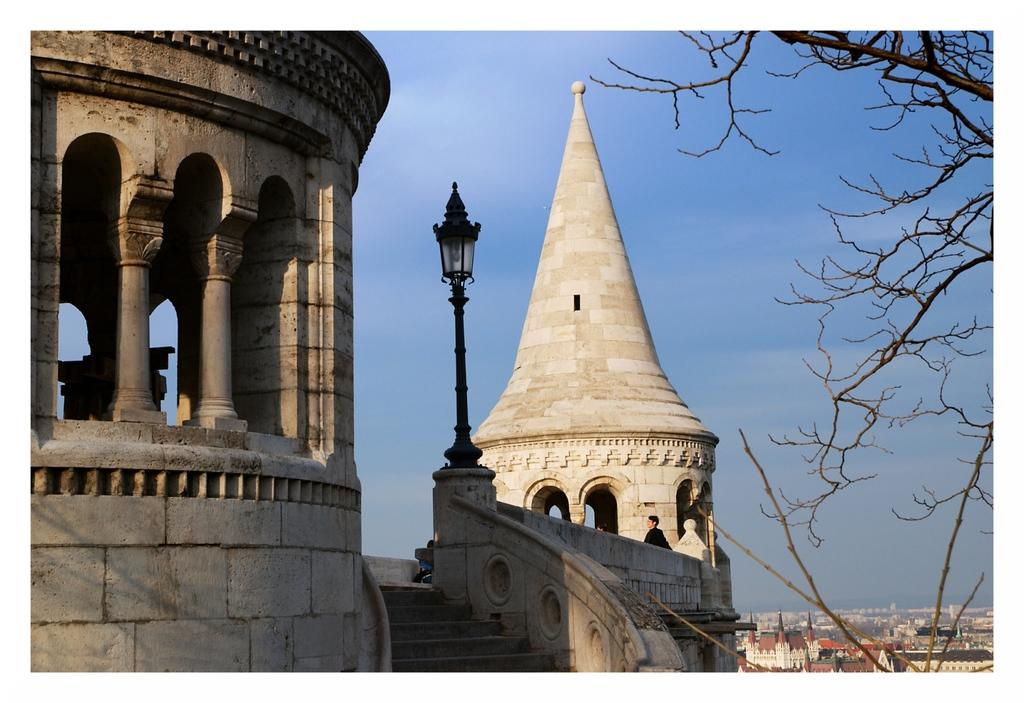What type of structures are present in the image? There are buildings in the image. Are there any living beings visible in the image? Yes, there are people in the image. What architectural feature can be seen at the bottom of the image? There are stairs at the bottom of the image. What object is present in the image that is typically used for support or guidance? There is a pole in the image. What type of vegetation is on the right side of the image? There is a tree on the right side of the image. What part of the natural environment is visible in the background of the image? The sky is visible in the background of the image. What type of soup is being served in the image? There is no soup present in the image. How many centimeters does the tree on the right side of the image measure? The image does not provide enough information to determine the exact height of the tree in centimeters. 